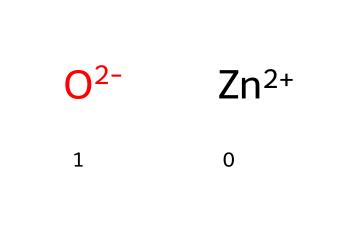How many atoms are present in this chemical structure? The chemical structure consists of one zinc atom (Zn) and one oxygen atom (O), which totals two atoms.
Answer: 2 What is the charge of zinc in this nanoparticles structure? The SMILES notation indicates zinc is represented as [Zn+2], which shows that it has a +2 charge.
Answer: +2 What is the role of zinc oxide nanoparticles in cosmetics? Zinc oxide nanoparticles are often used in cosmetics for their UV protection and antioxidant properties, which contribute to anti-aging effects.
Answer: UV protection What is the oxidation state of the oxygen in the nanoparticles? The notation [O-2] indicates that oxygen has a -2 charge, which represents its oxidation state in this context.
Answer: -2 Why are zinc oxide nanoparticles beneficial for anti-aging products? Zinc oxide nanoparticles are effective in protecting the skin from UV radiation, which helps prevent photoaging, and they can also act as a skin-soothing agent.
Answer: photoaging What type of bonding is present between zinc and oxygen in this structure? The bonding in this nanoparticles structure is ionic, as indicated by the charges (+2 for zinc and -2 for oxygen), which is typical for metal oxides.
Answer: ionic 